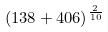Convert formula to latex. <formula><loc_0><loc_0><loc_500><loc_500>( 1 3 8 + 4 0 6 ) ^ { \frac { 2 } { 1 0 } }</formula> 